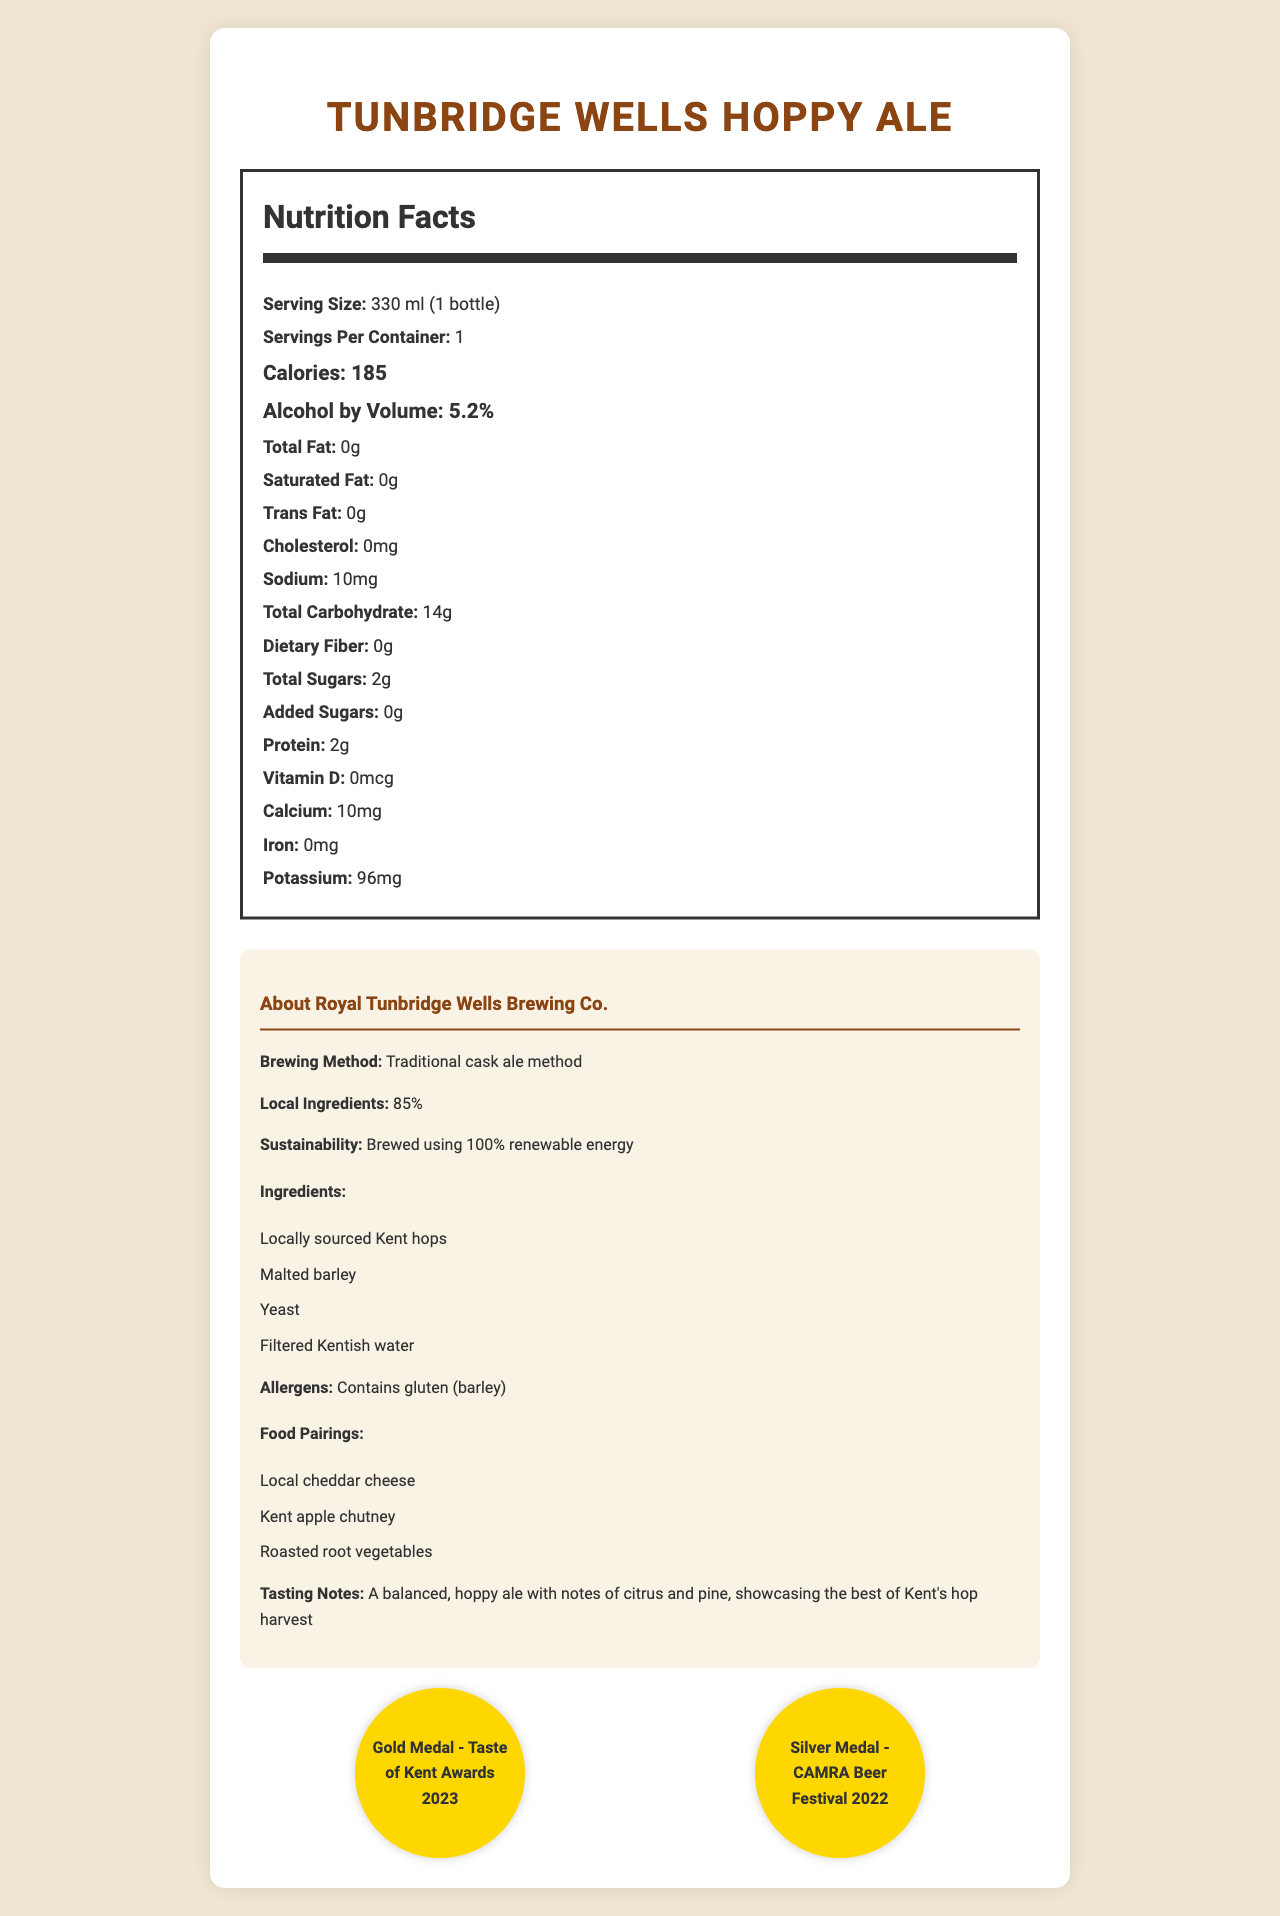what is the serving size of Tunbridge Wells Hoppy Ale? The serving size is specified in the Nutrition Facts section of the document.
Answer: 330 ml (1 bottle) how many calories are in one serving of Tunbridge Wells Hoppy Ale? The calorie content is mentioned under the Nutrition Facts section as 185 calories per serving.
Answer: 185 what is the alcohol by volume (ABV) percentage of Tunbridge Wells Hoppy Ale? The ABV is clearly stated in the Nutrition Facts section as 5.2%.
Answer: 5.2% what is the total carbohydrate content in Tunbridge Wells Hoppy Ale? The total carbohydrate content is listed under the Nutrition Facts as 14 grams.
Answer: 14g what are the main ingredients of Tunbridge Wells Hoppy Ale? The ingredients are listed in the "About Royal Tunbridge Wells Brewing Co." section.
Answer: Locally sourced Kent hops, Malted barley, Yeast, Filtered Kentish water how much sodium is in a serving of Tunbridge Wells Hoppy Ale? A. 5mg B. 10mg C. 15mg D. 20mg The sodium content is 10 mg per serving, as stated in the Nutrition Facts section.
Answer: B which award did Tunbridge Wells Hoppy Ale win in 2023? I. Gold Medal - Taste of Kent Awards II. Silver Medal - CAMRA Beer Festival III. Bronze Medal - International Beer Challenge Tunbridge Wells Hoppy Ale won the Gold Medal at the Taste of Kent Awards 2023, as mentioned in the awards section.
Answer: I does Tunbridge Wells Hoppy Ale contain any gluten? The document mentions that the ale contains barley and therefore gluten in the allergen information.
Answer: Yes what brewing method is used for Tunbridge Wells Hoppy Ale? The brewing method is specified as the "Traditional cask ale method" in the "About Royal Tunbridge Wells Brewing Co." section.
Answer: Traditional cask ale method is all the energy used to brew Tunbridge Wells Hoppy Ale renewable? The sustainability information states that the ale is brewed using 100% renewable energy.
Answer: Yes summarize the main idea of the document The document includes various sections detailing nutritional facts, ingredients, allergen information, sustainability practices, food pairings, awards, and tasting notes about Tunbridge Wells Hoppy Ale, emphasizing its local and environmentally conscious production.
Answer: The document provides detailed nutritional information and other relevant details about Tunbridge Wells Hoppy Ale, including its serving size, calorie content, alcohol percentage, and ingredient list. It highlights the use of local ingredients and the environmentally friendly brewing methods used. It also mentions awards won, suitable food pairings, and tasting notes. what is the percentage of local ingredients used in Tunbridge Wells Hoppy Ale? The percentage of local ingredients is listed as 85% in the "About Royal Tunbridge Wells Brewing Co." section.
Answer: 85% how many grams of protein are in a serving of Tunbridge Wells Hoppy Ale? The protein content is 2 grams per serving, as mentioned in the Nutrition Facts section.
Answer: 2g what type of cheese is suggested as a pairing for Tunbridge Wells Hoppy Ale? The food pairings section suggests pairing the ale with local cheddar cheese.
Answer: Local cheddar cheese does Tunbridge Wells Hoppy Ale contain any added sugars? The Nutrition Facts section lists 0 grams of added sugars.
Answer: No what is the exact brewing method used for Tunbridge Wells Hoppy Ale? The document only mentions the traditional cask ale method but does not go into brewing specifics beyond that.
Answer: Cannot be determined 